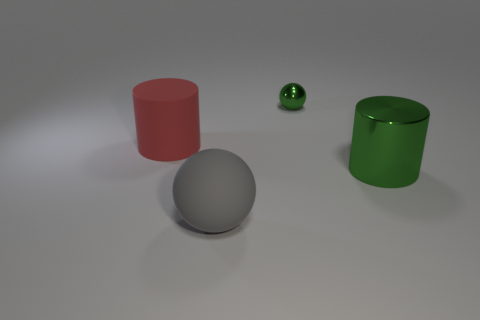Does the large shiny thing have the same color as the tiny ball?
Make the answer very short. Yes. What size is the sphere behind the big gray sphere?
Your answer should be very brief. Small. Is there a shiny cylinder that has the same size as the gray rubber sphere?
Make the answer very short. Yes. Is the size of the green metal thing in front of the red object the same as the rubber sphere?
Your answer should be compact. Yes. The gray ball has what size?
Make the answer very short. Large. There is a big cylinder on the left side of the sphere that is behind the big rubber thing on the left side of the large gray rubber ball; what is its color?
Provide a succinct answer. Red. There is a matte object to the left of the large gray thing; does it have the same color as the small object?
Your response must be concise. No. How many big objects are both to the left of the small green metal ball and right of the rubber cylinder?
Make the answer very short. 1. There is a green object that is the same shape as the large red rubber object; what is its size?
Offer a terse response. Large. What number of small metallic balls are left of the thing that is in front of the green shiny thing in front of the green shiny ball?
Offer a terse response. 0. 